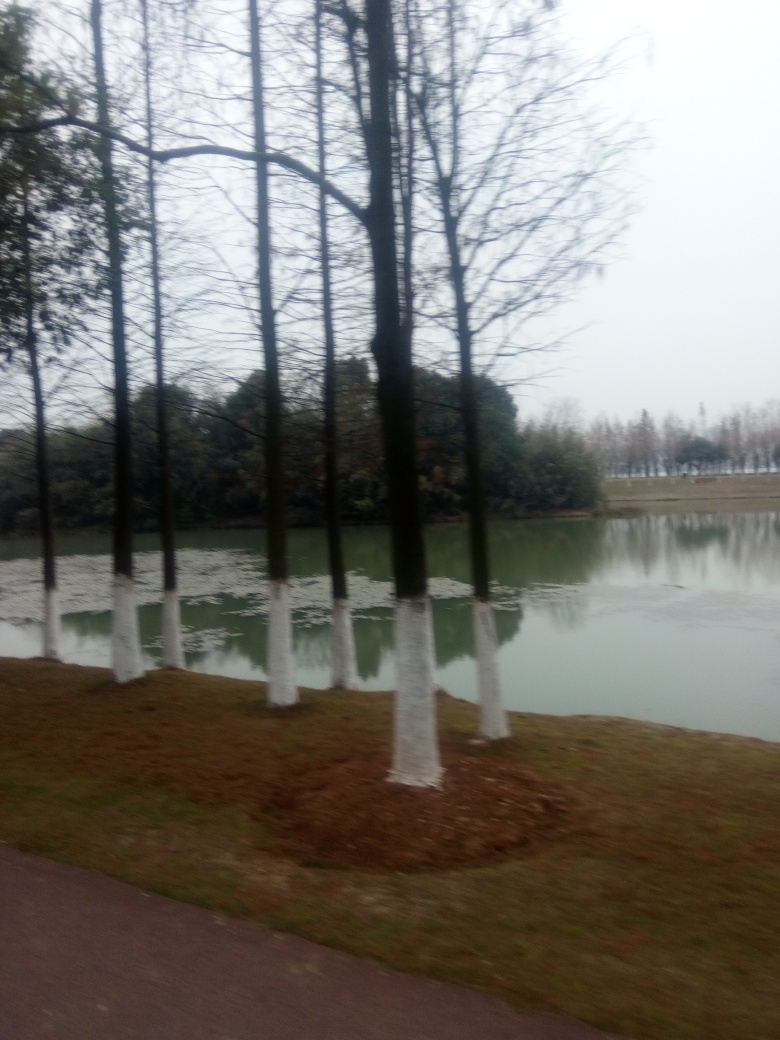What time of day does this image appear to have been taken? The overcast sky and lack of shadows suggest it could be an image taken on a cloudy day, likely during daylight hours, but the specific time of day isn't discernible due to the image's overall lack of clarity. 